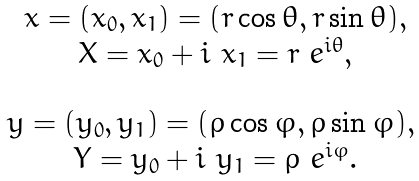<formula> <loc_0><loc_0><loc_500><loc_500>\begin{array} { c } x = ( x _ { 0 } , x _ { 1 } ) = ( r \cos \theta , r \sin \theta ) , \\ X = x _ { 0 } + i \ x _ { 1 } = r \ e ^ { i \theta } , \\ \\ y = ( y _ { 0 } , y _ { 1 } ) = ( \rho \cos \varphi , \rho \sin \varphi ) , \ \\ Y = y _ { 0 } + i \ y _ { 1 } = \rho \ e ^ { i \varphi } . \end{array}</formula> 